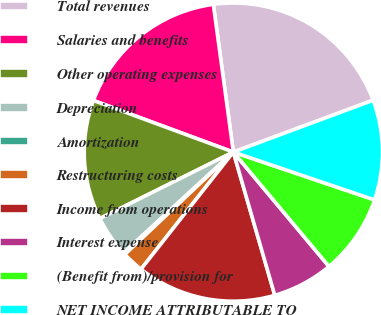Convert chart to OTSL. <chart><loc_0><loc_0><loc_500><loc_500><pie_chart><fcel>Total revenues<fcel>Salaries and benefits<fcel>Other operating expenses<fcel>Depreciation<fcel>Amortization<fcel>Restructuring costs<fcel>Income from operations<fcel>Interest expense<fcel>(Benefit from)/provision for<fcel>NET INCOME ATTRIBUTABLE TO<nl><fcel>21.49%<fcel>17.23%<fcel>12.98%<fcel>4.47%<fcel>0.21%<fcel>2.34%<fcel>15.11%<fcel>6.6%<fcel>8.72%<fcel>10.85%<nl></chart> 